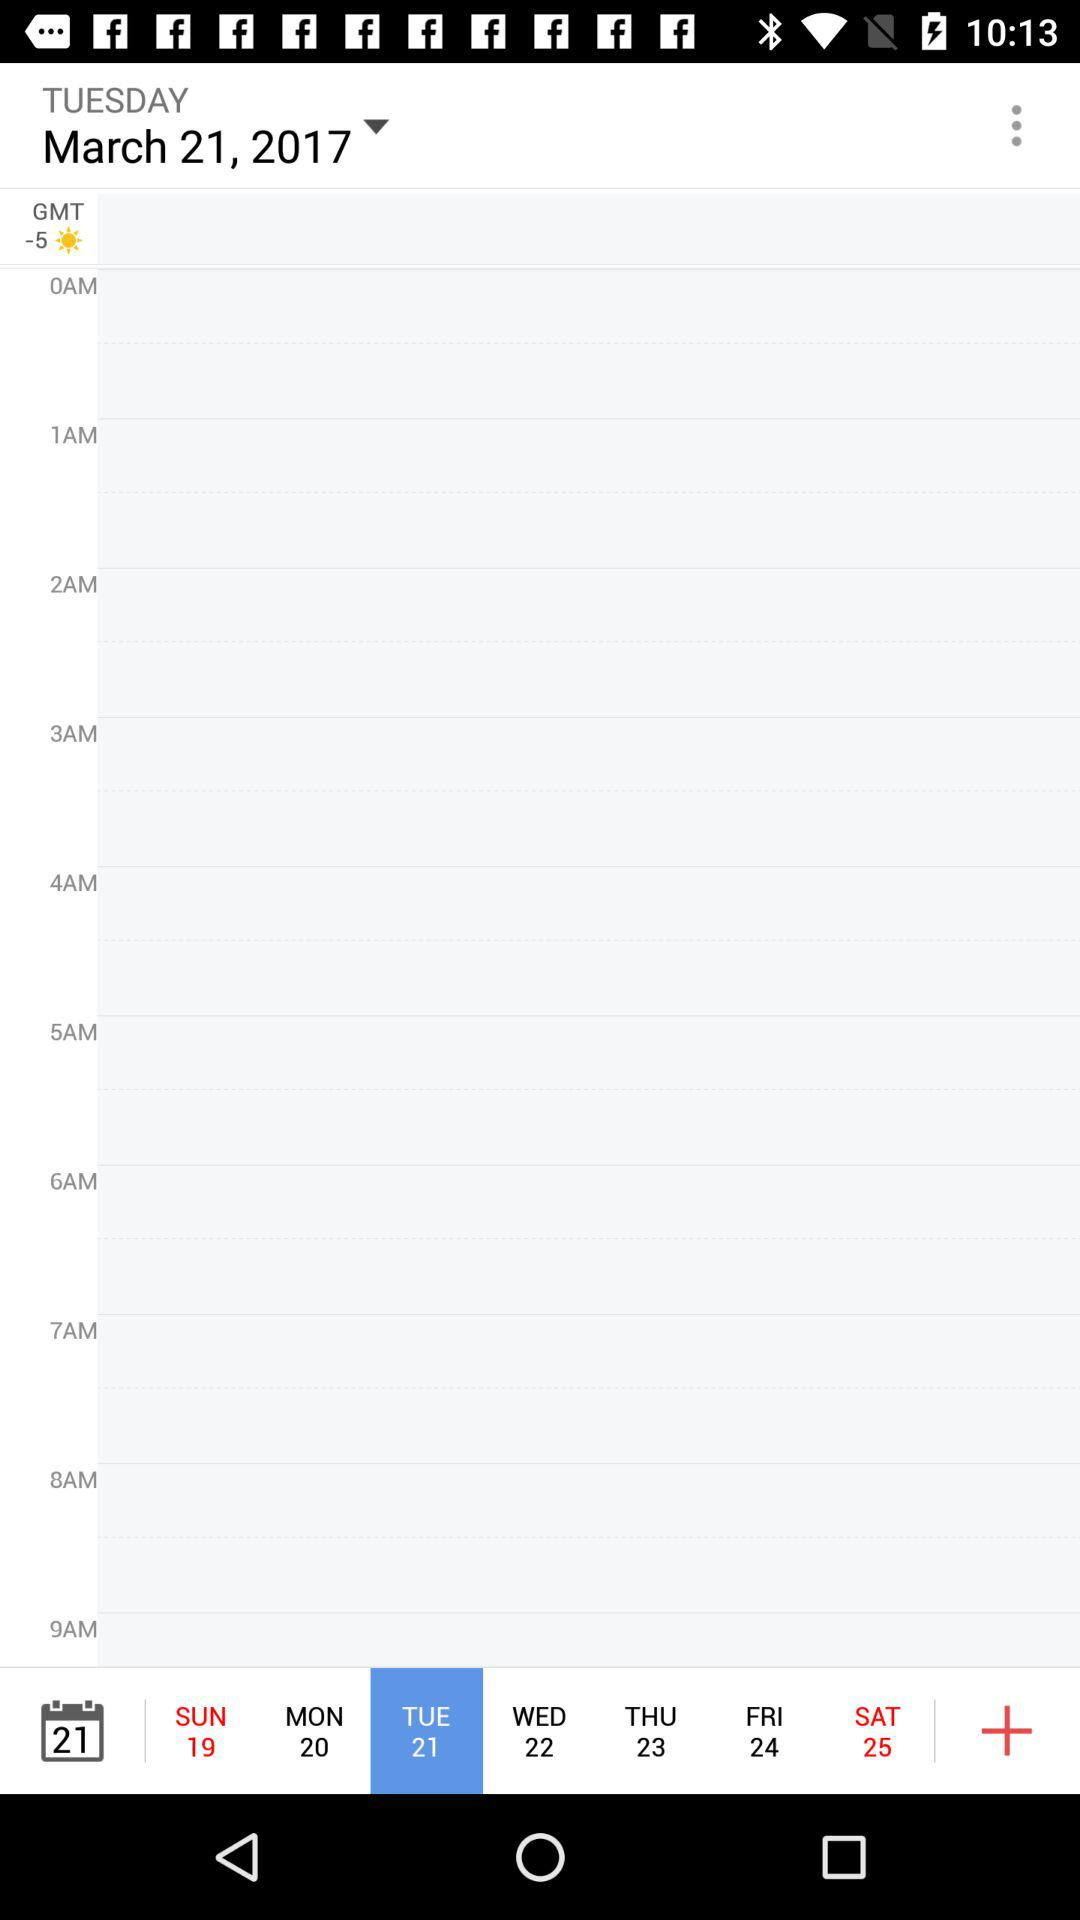What day falls on the 20th on the calendar? The day that falls on the 20th on the calendar is Monday. 